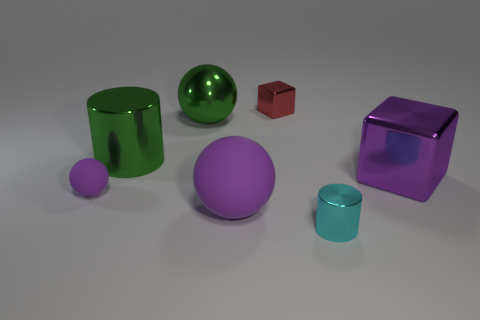Do the big green sphere and the cyan cylinder have the same material?
Your response must be concise. Yes. There is a small thing that is left of the small red block; are there any tiny cyan cylinders behind it?
Your response must be concise. No. How many small metal objects are behind the big purple block and right of the small block?
Provide a short and direct response. 0. What is the shape of the big thing that is on the right side of the cyan metallic cylinder?
Give a very brief answer. Cube. What number of purple things have the same size as the shiny ball?
Offer a very short reply. 2. There is a rubber object right of the big green metal cylinder; is it the same color as the tiny rubber object?
Your response must be concise. Yes. What is the material of the purple thing that is both left of the purple shiny block and on the right side of the small purple rubber sphere?
Provide a succinct answer. Rubber. Is the number of matte objects greater than the number of tiny brown matte balls?
Keep it short and to the point. Yes. There is a shiny cube that is left of the cylinder in front of the big shiny object right of the large metal ball; what color is it?
Your answer should be very brief. Red. Is the material of the cube to the left of the tiny cyan cylinder the same as the small ball?
Give a very brief answer. No. 